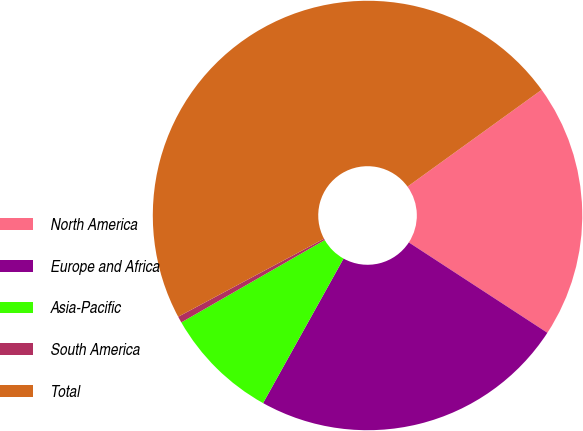Convert chart. <chart><loc_0><loc_0><loc_500><loc_500><pie_chart><fcel>North America<fcel>Europe and Africa<fcel>Asia-Pacific<fcel>South America<fcel>Total<nl><fcel>19.15%<fcel>23.89%<fcel>8.62%<fcel>0.48%<fcel>47.87%<nl></chart> 